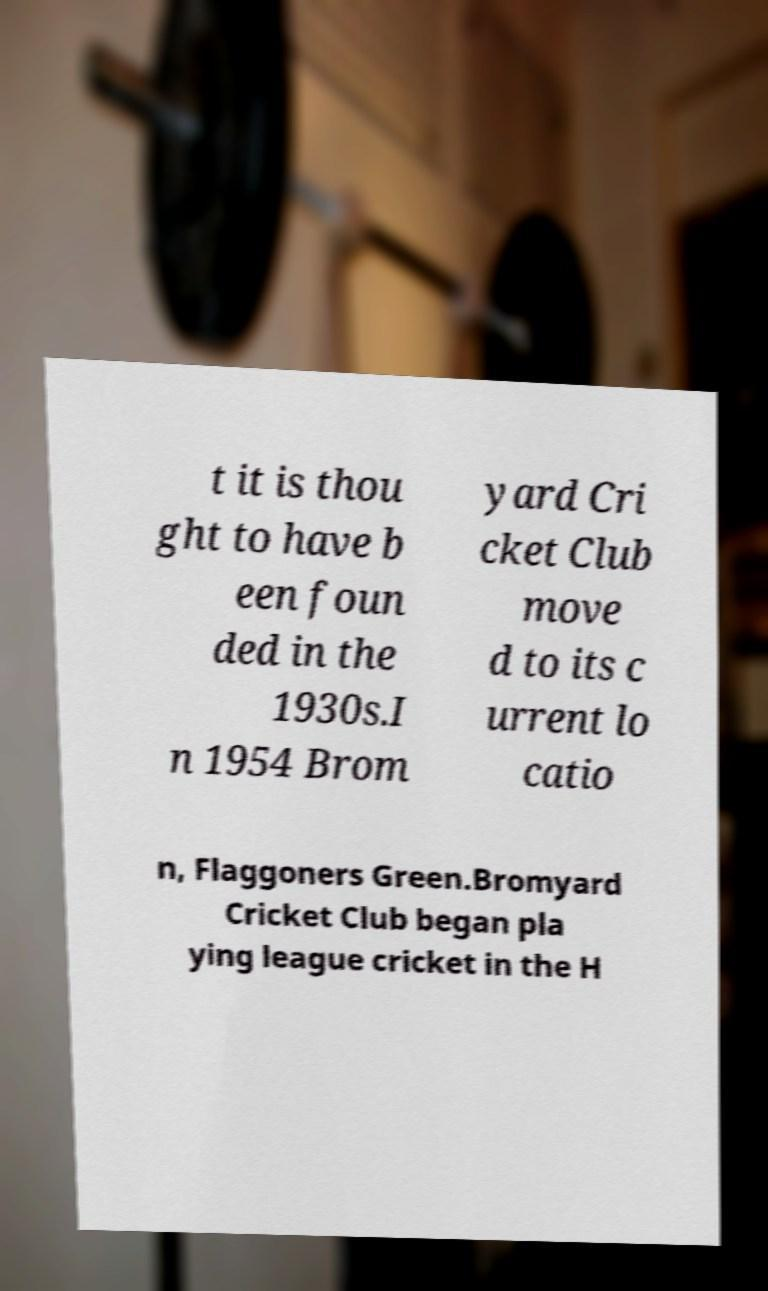Please read and relay the text visible in this image. What does it say? t it is thou ght to have b een foun ded in the 1930s.I n 1954 Brom yard Cri cket Club move d to its c urrent lo catio n, Flaggoners Green.Bromyard Cricket Club began pla ying league cricket in the H 